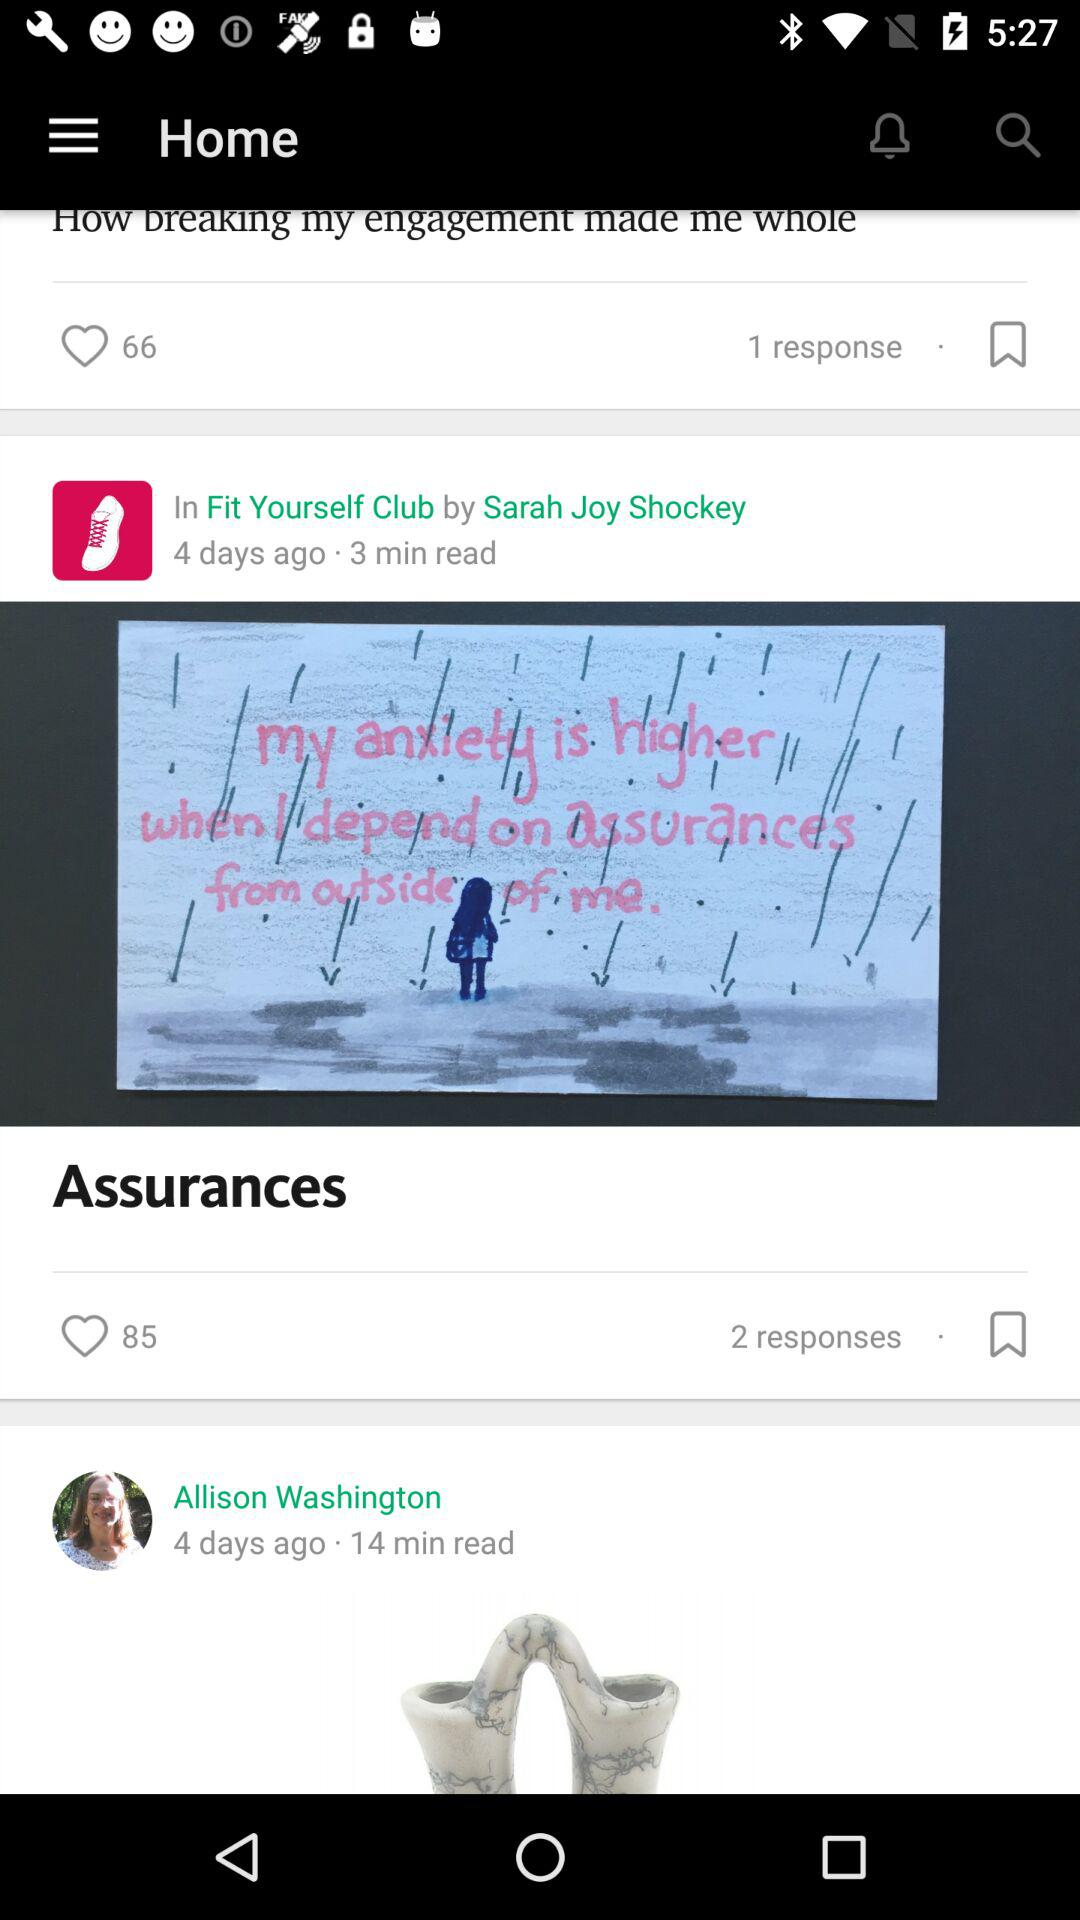How many more hearts does the Assurances article have than the How breaking my engagement made me whole article?
Answer the question using a single word or phrase. 19 